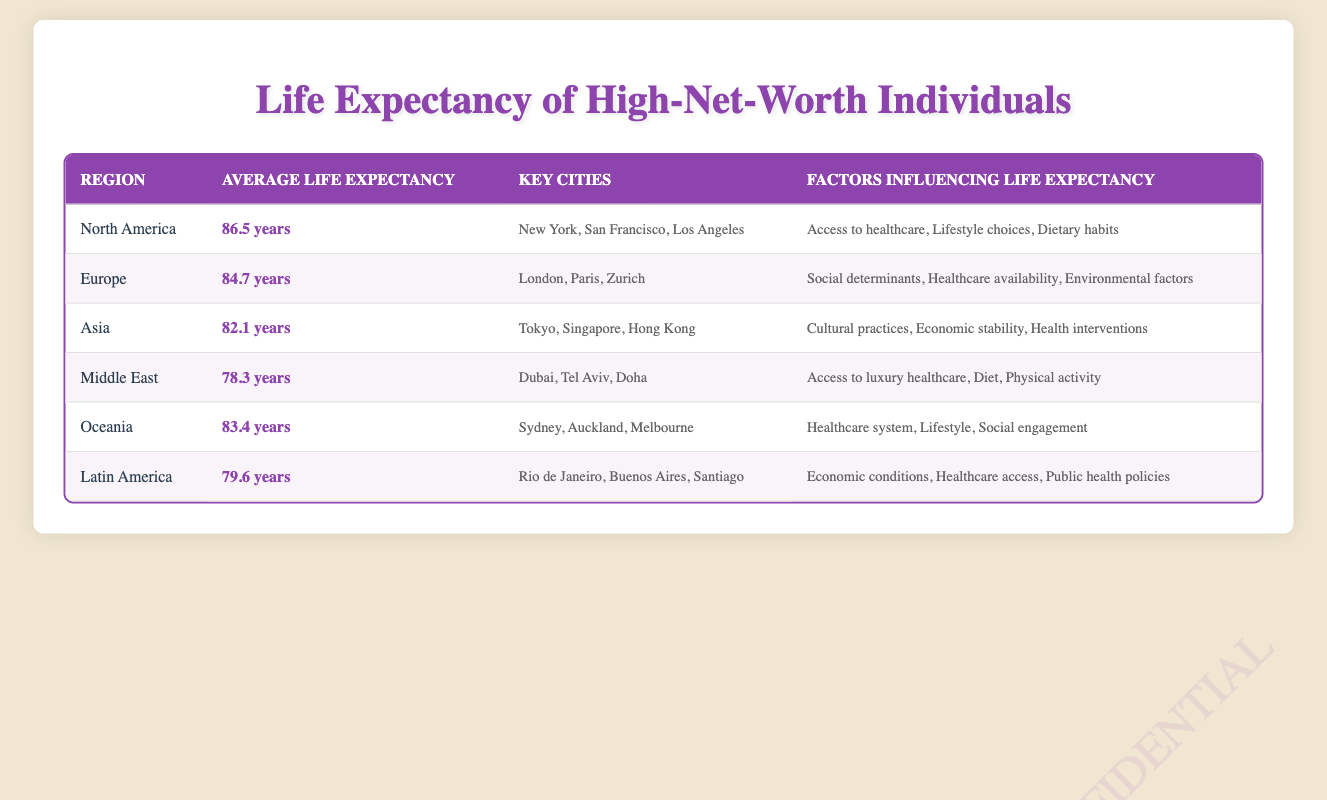What is the average life expectancy of high-net-worth individuals in North America? The table lists the average life expectancy for high-net-worth individuals in North America as 86.5 years. This value can be directly retrieved from the corresponding row in the table.
Answer: 86.5 years Which region has the lowest average life expectancy? By examining the average life expectancy column, Latin America has the lowest average life expectancy at 79.6 years, which is less than all other regions.
Answer: Latin America What are the key cities for high-net-worth individuals in Europe? The table lists London, Paris, and Zurich as the key cities for high-net-worth individuals in Europe. This information is found in the corresponding row under the "Key Cities" column.
Answer: London, Paris, Zurich If we take the average life expectancy of North America and Oceania, what is the result? The average life expectancy for North America is 86.5 years, and for Oceania it is 83.4 years. To find the average of these two values, we sum them: 86.5 + 83.4 = 169.9. Then we divide by 2, resulting in 169.9 / 2 = 84.95 years.
Answer: 84.95 years Is it true that Asia has a higher average life expectancy than the Middle East? The average life expectancy for Asia is 82.1 years while for the Middle East it is 78.3 years. Since 82.1 is greater than 78.3, the statement is true.
Answer: Yes Which factors influence life expectancy in high-net-worth individuals in Oceania? The table indicates that the factors influencing life expectancy in Oceania include the healthcare system, lifestyle, and social engagement. These factors can be found listed under the "Factors Influencing Life Expectancy" column for Oceania.
Answer: Healthcare system, lifestyle, social engagement What is the difference in average life expectancy between Europe and Latin America? The average life expectancy for Europe is 84.7 years and for Latin America is 79.6 years. To find the difference, subtract the Latin American life expectancy from that of Europe: 84.7 - 79.6 = 5.1 years.
Answer: 5.1 years Which region has factors related to luxury healthcare influencing life expectancy? Looking at the table, the Middle East lists "Access to luxury healthcare" among its factors influencing life expectancy, which can be verified in the corresponding row.
Answer: Middle East If you combine the average life expectancy of Europe and Oceania, what do you get? The average life expectancy for Europe is 84.7 years and for Oceania is 83.4 years. To combine, sum these two values: 84.7 + 83.4 = 168.1 years. The total for both regions is 168.1 years.
Answer: 168.1 years 